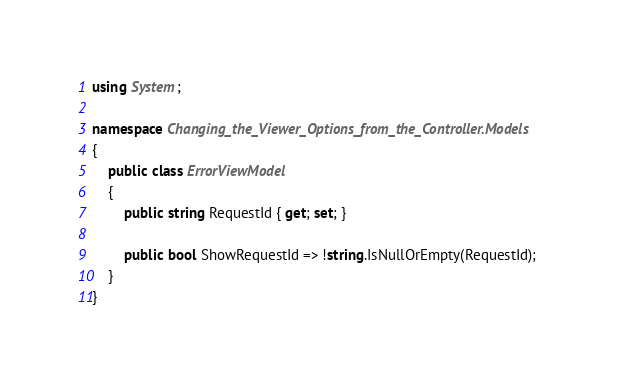Convert code to text. <code><loc_0><loc_0><loc_500><loc_500><_C#_>using System;

namespace Changing_the_Viewer_Options_from_the_Controller.Models
{
    public class ErrorViewModel
    {
        public string RequestId { get; set; }

        public bool ShowRequestId => !string.IsNullOrEmpty(RequestId);
    }
}
</code> 